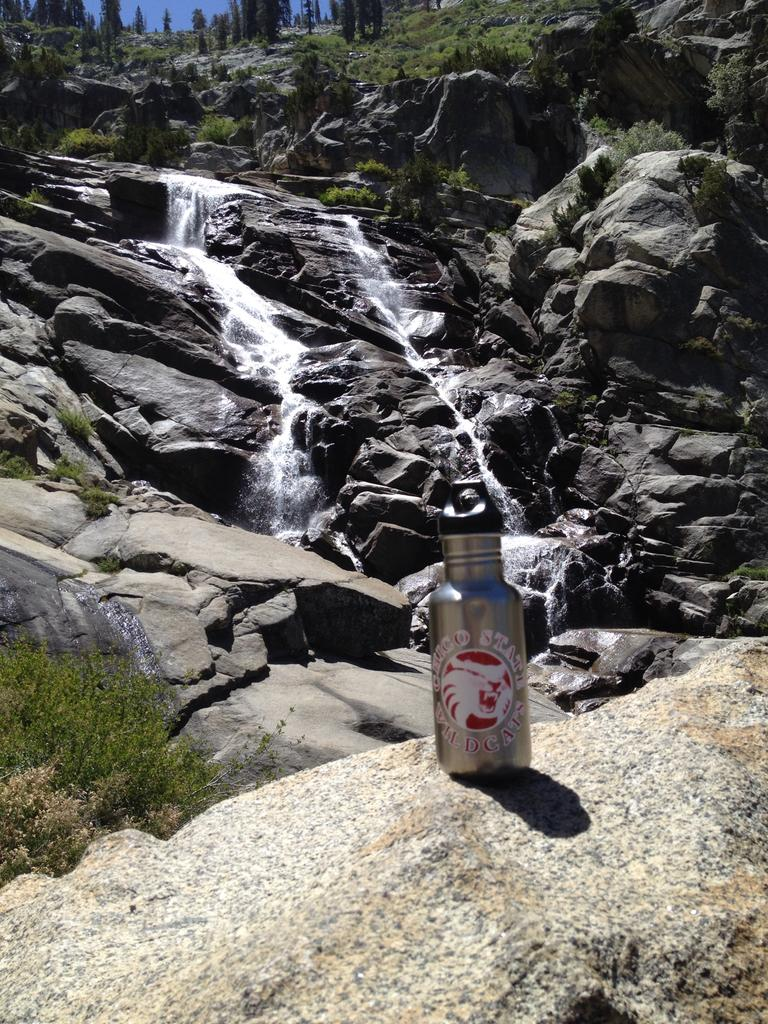Where was the image taken? The image was clicked outside. What is the main feature in the middle of the image? There are waterfalls in the middle of the image. What type of vegetation can be seen at the top of the image? There are trees at the top of the image. What item is visible in the middle of the image, besides the waterfalls? There is a water bottle in the middle of the image. What type of force is being applied to the cabbage in the image? There is no cabbage present in the image, so no force is being applied to it. 